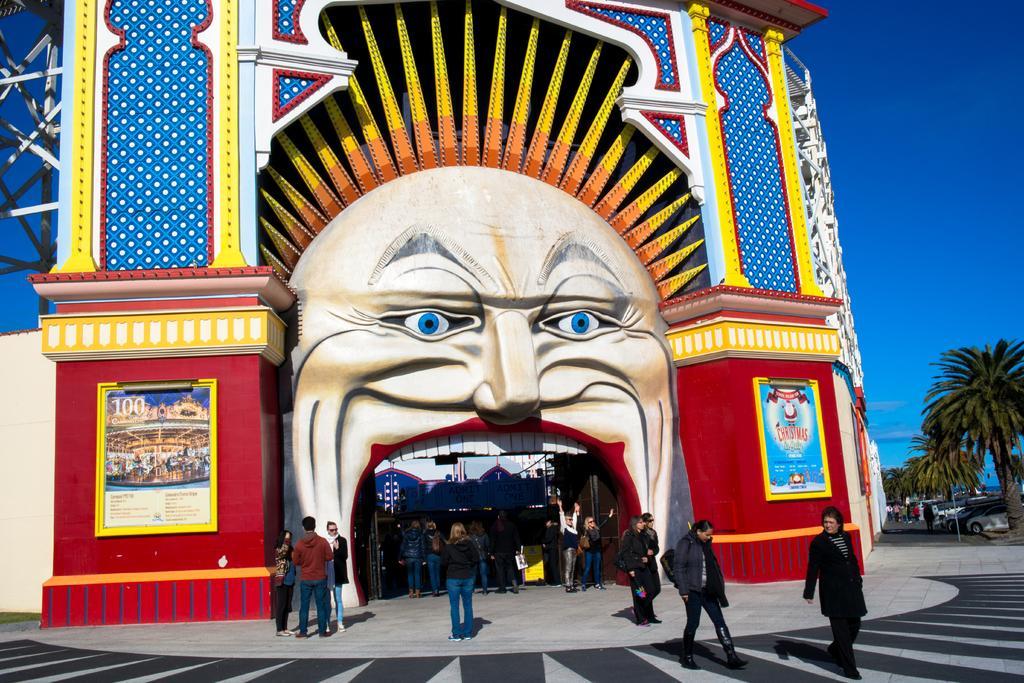Describe this image in one or two sentences. In this image I can see people on the ground. On the right side I can see vehicles and trees. In the background I can see the sky. 